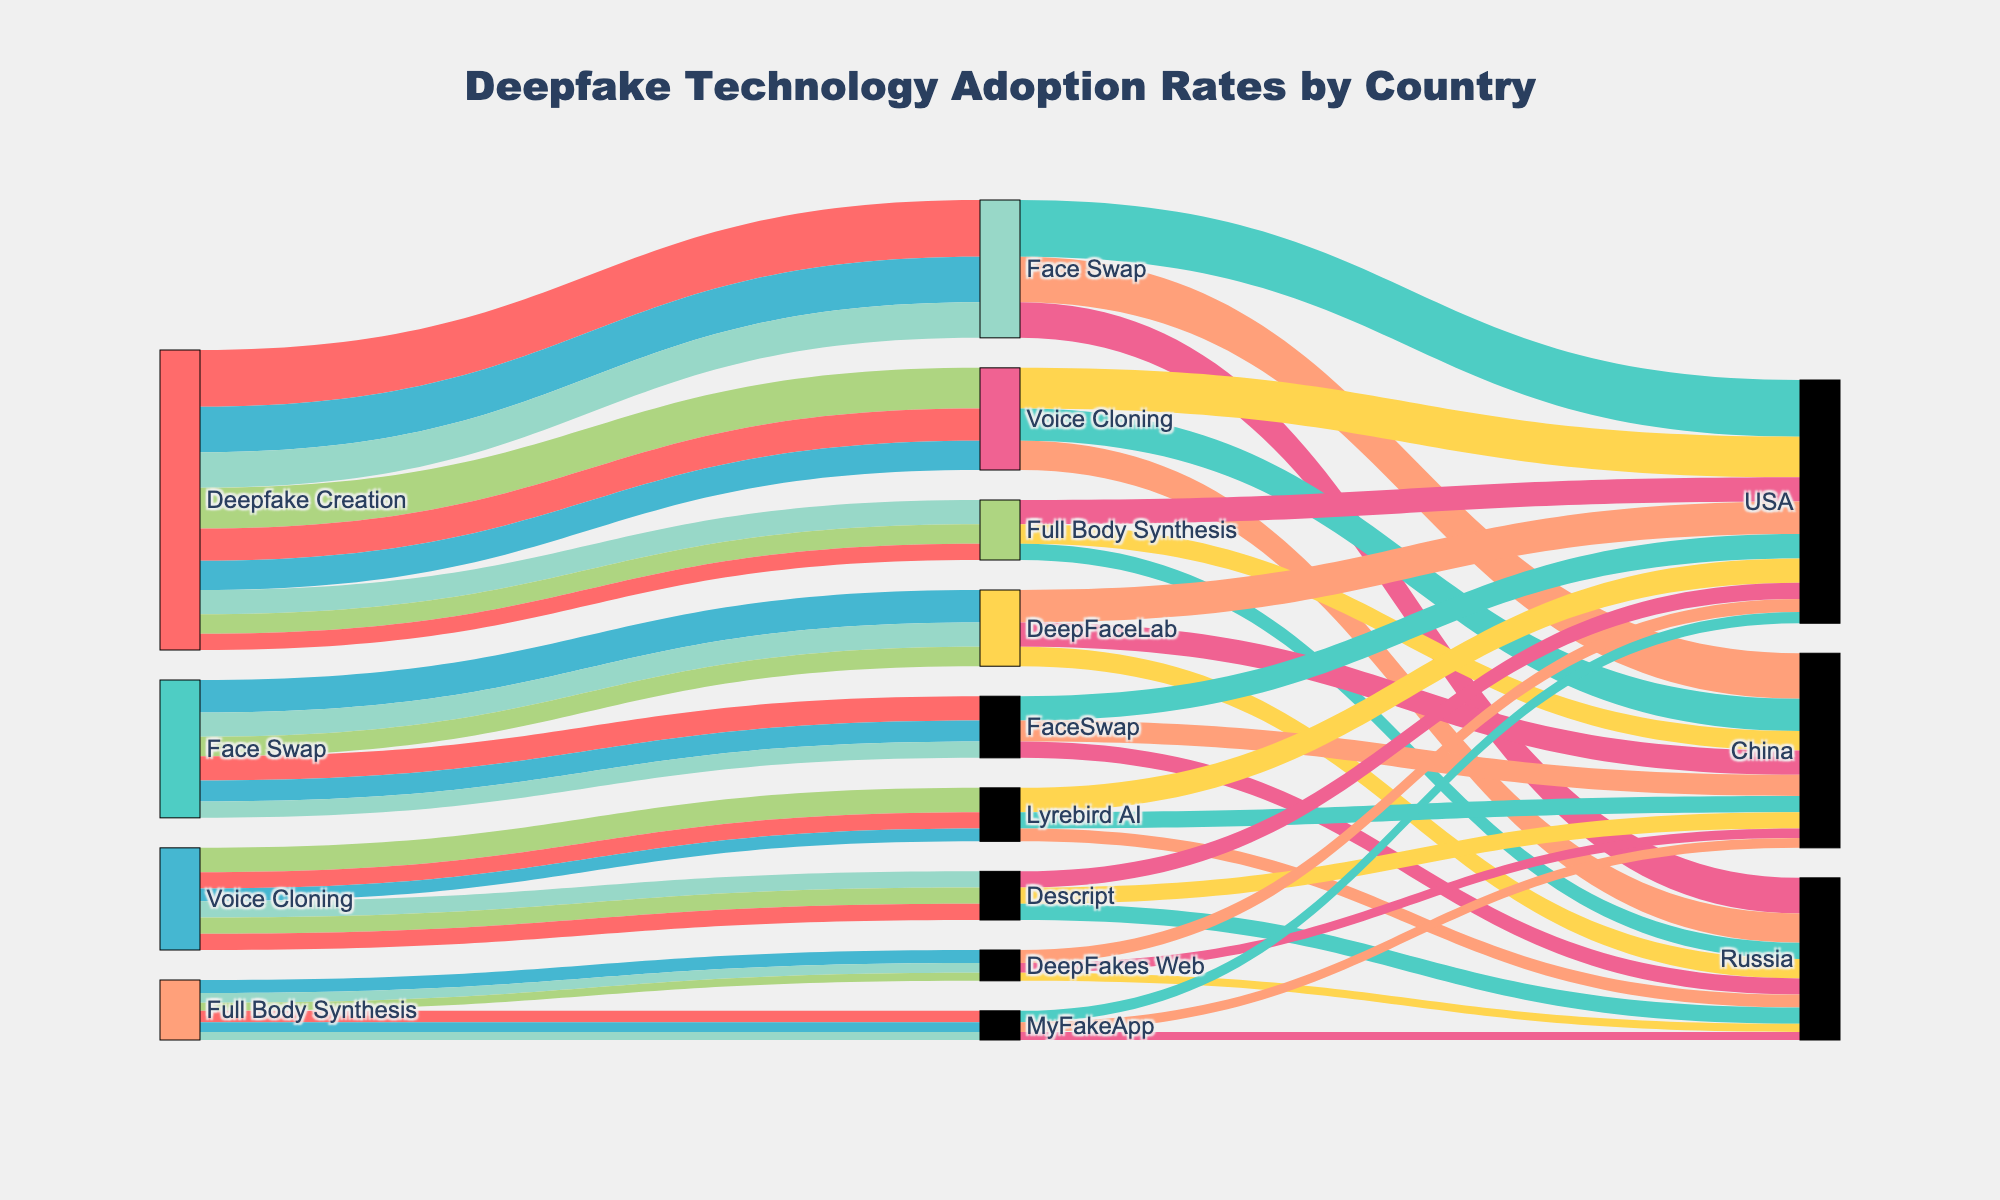What's the title of the figure? The title is a textual element positioned prominently at the top of the figure, indicating the subject of the visualization. It provides a quick understanding of what the figure represents.
Answer: Deepfake Technology Adoption Rates by Country What are the main categories of deepfake creation technologies shown in the figure? These categories are represented by unique nodes at the first level of the diagram, which branches off into more specific technologies.
Answer: Face Swap, Voice Cloning, Full Body Synthesis Which country has the highest adoption rate for DeepFaceLab under Face Swap technology? To find this, follow the path from Face Swap to DeepFaceLab, and then from DeepFaceLab to the countries, comparing their adoption rates.
Answer: USA How many different deepfake creation technologies are detailed within the Face Swap category? Follow the path from Face Swap and count the unique nodes that represent the technologies under this category.
Answer: 2 Which deepfake technology has the lowest adoption rate in Russia? Compare the adoption rates of all three deepfake technologies within Russia to identify the lowest one.
Answer: Full Body Synthesis What is the combined adoption rate of Voice Cloning technology in all countries? Add up the adoption rates of Voice Cloning in the USA, China, and Russia. 25 (USA) + 20 (China) + 18 (Russia) = 63
Answer: 63 By how much does the adoption rate of Face Swap in the USA surpass that in Russia? Subtract Russia's adoption rate for Face Swap from the USA's adoption rate for the same technology. 35 (USA) - 22 (Russia) = 13
Answer: 13 Which country has the highest overall adoption rate for Full Body Synthesis technology? Compare the adoption rates of Full Body Synthesis technology across the USA, China, and Russia to find the highest one.
Answer: USA How does the adoption rate of Voice Cloning in China compare to its adoption rate in Russia? Examine the respective adoption rates of Voice Cloning in China and Russia and state if one is higher, lower, or equal. 20 (China) vs. 18 (Russia)
Answer: Higher Which deepfake technology has the most balanced adoption rates across all countries? Analyze the adoption rates of each deepfake technology across the three countries, identifying which one has the smallest range of differences. Full Body Synthesis: 15 (USA), 12 (China), 10 (Russia)
Answer: Full Body Synthesis 